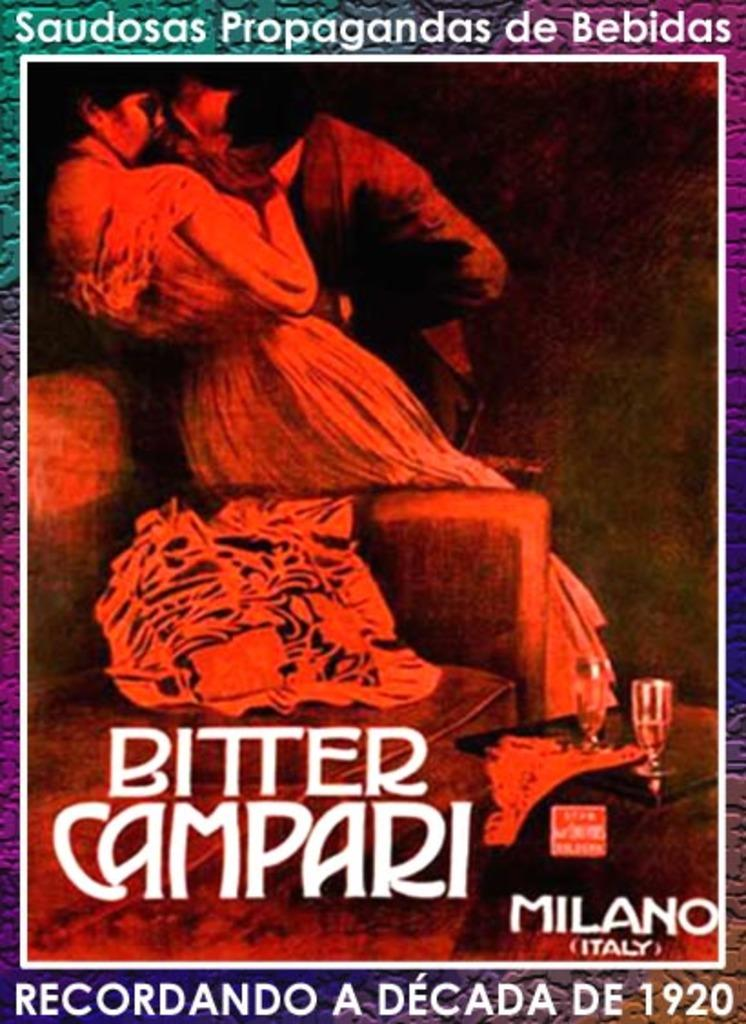<image>
Render a clear and concise summary of the photo. A poster with a man and woman on it showing the location is Milano Italy. 